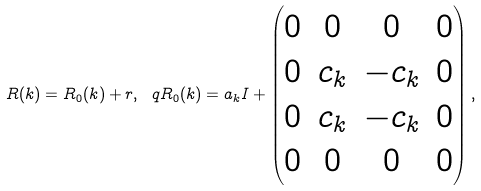Convert formula to latex. <formula><loc_0><loc_0><loc_500><loc_500>R ( k ) = R _ { 0 } ( k ) + r , \ q R _ { 0 } ( k ) = a _ { k } I + \begin{pmatrix} 0 & 0 & 0 & 0 \\ 0 & c _ { k } & - c _ { k } & 0 \\ 0 & c _ { k } & - c _ { k } & 0 \\ 0 & 0 & 0 & 0 \end{pmatrix} ,</formula> 